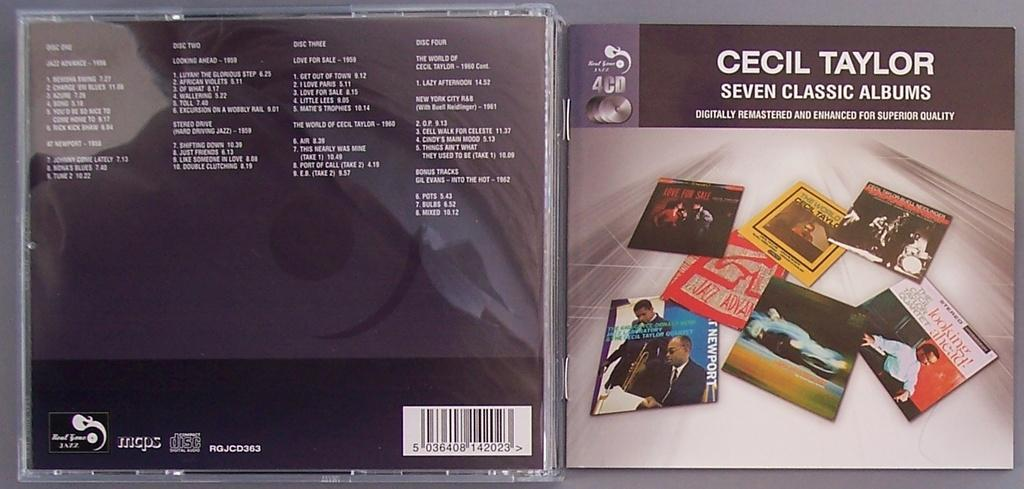<image>
Provide a brief description of the given image. The front and the back of Cecil Taylor's CD is shown. 